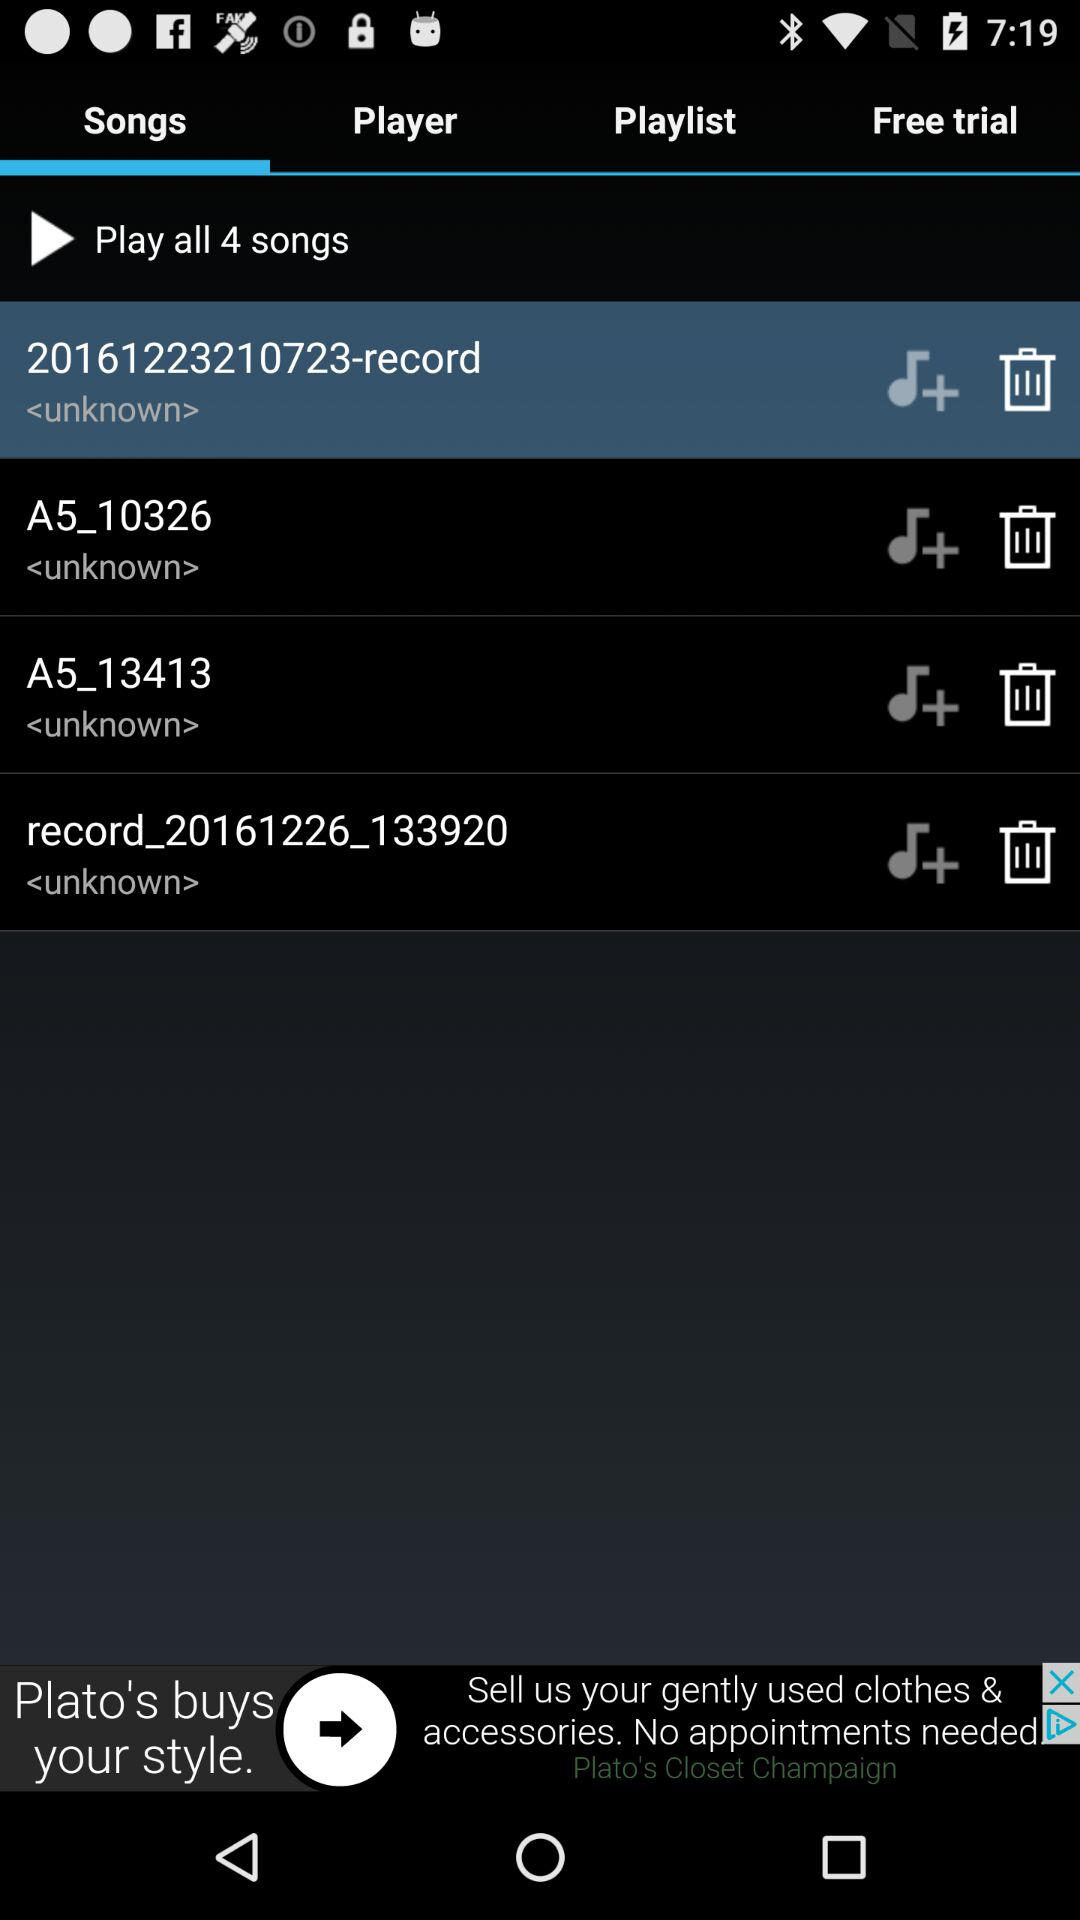Which tab is selected? The selected tab is "Songs". 